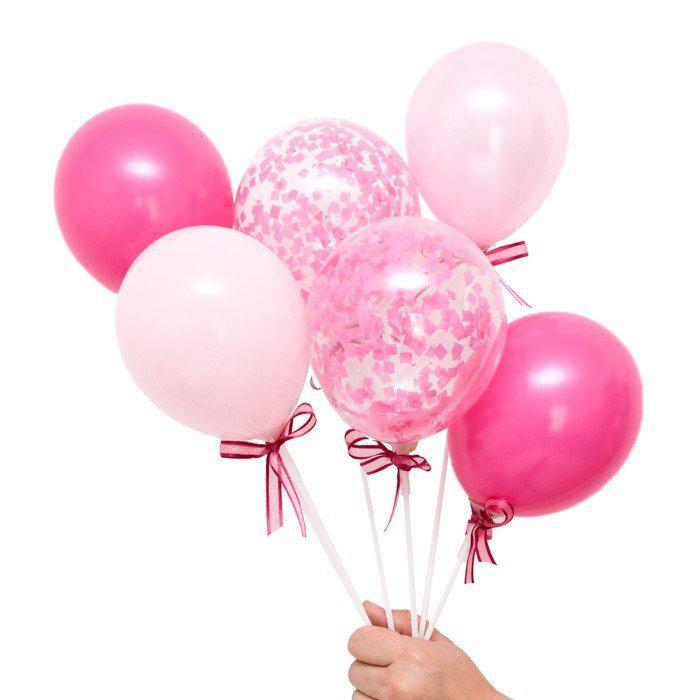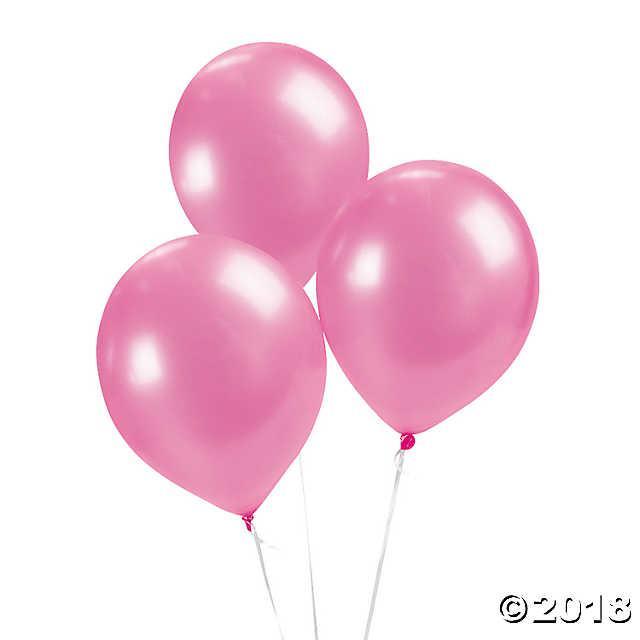The first image is the image on the left, the second image is the image on the right. For the images displayed, is the sentence "There are more balloons in the image on the left." factually correct? Answer yes or no. Yes. The first image is the image on the left, the second image is the image on the right. Evaluate the accuracy of this statement regarding the images: "There are no less than 19 balloons.". Is it true? Answer yes or no. No. 